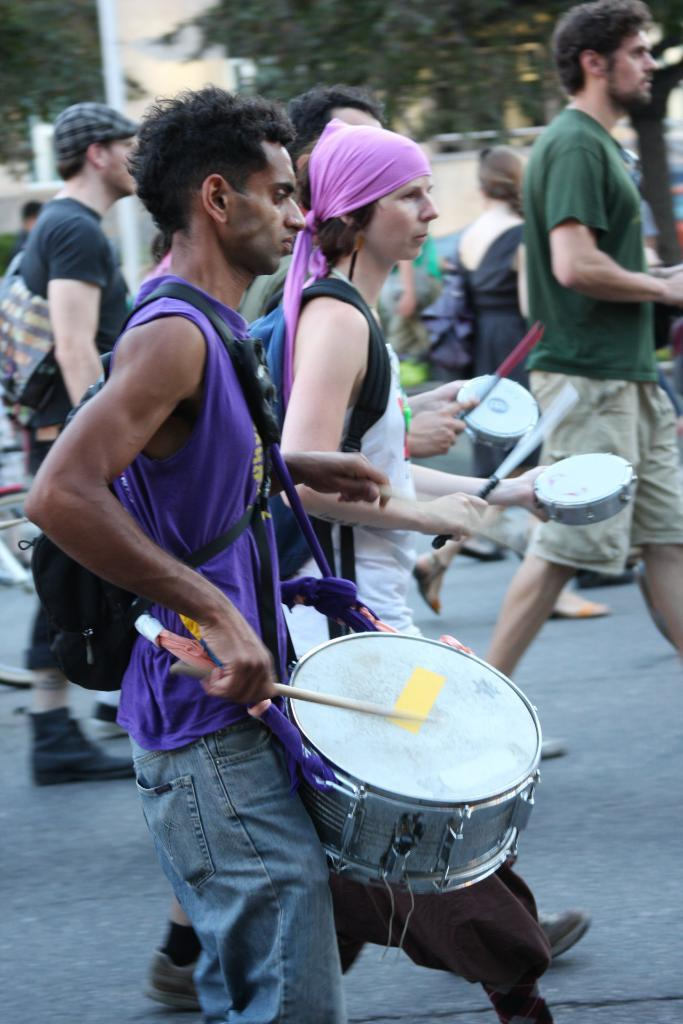What are the people in the image doing? There are persons walking on the road in the image. Is there any musical activity happening in the image? Yes, one person is playing drums. What type of vegetation can be seen in the image? There is a tree visible in the image. What type of pathway is present in the image? There is a road in the image. What is the daughter's name in the image? There is no mention of a daughter or any names in the image. Can you tell me how many pockets the tree has in the image? Trees do not have pockets, so this question cannot be answered. 